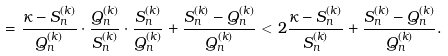Convert formula to latex. <formula><loc_0><loc_0><loc_500><loc_500>= \frac { \kappa - S _ { n } ^ { ( k ) } } { Q _ { n } ^ { ( k ) } } \cdot \frac { Q _ { n } ^ { ( k ) } } { S _ { n } ^ { ( k ) } } \cdot \frac { S _ { n } ^ { ( k ) } } { Q _ { n } ^ { ( k ) } } + \frac { S _ { n } ^ { ( k ) } - Q _ { n } ^ { ( k ) } } { Q _ { n } ^ { ( k ) } } < 2 \frac { \kappa - S _ { n } ^ { ( k ) } } { S _ { n } ^ { ( k ) } } + \frac { S _ { n } ^ { ( k ) } - Q _ { n } ^ { ( k ) } } { Q _ { n } ^ { ( k ) } } .</formula> 